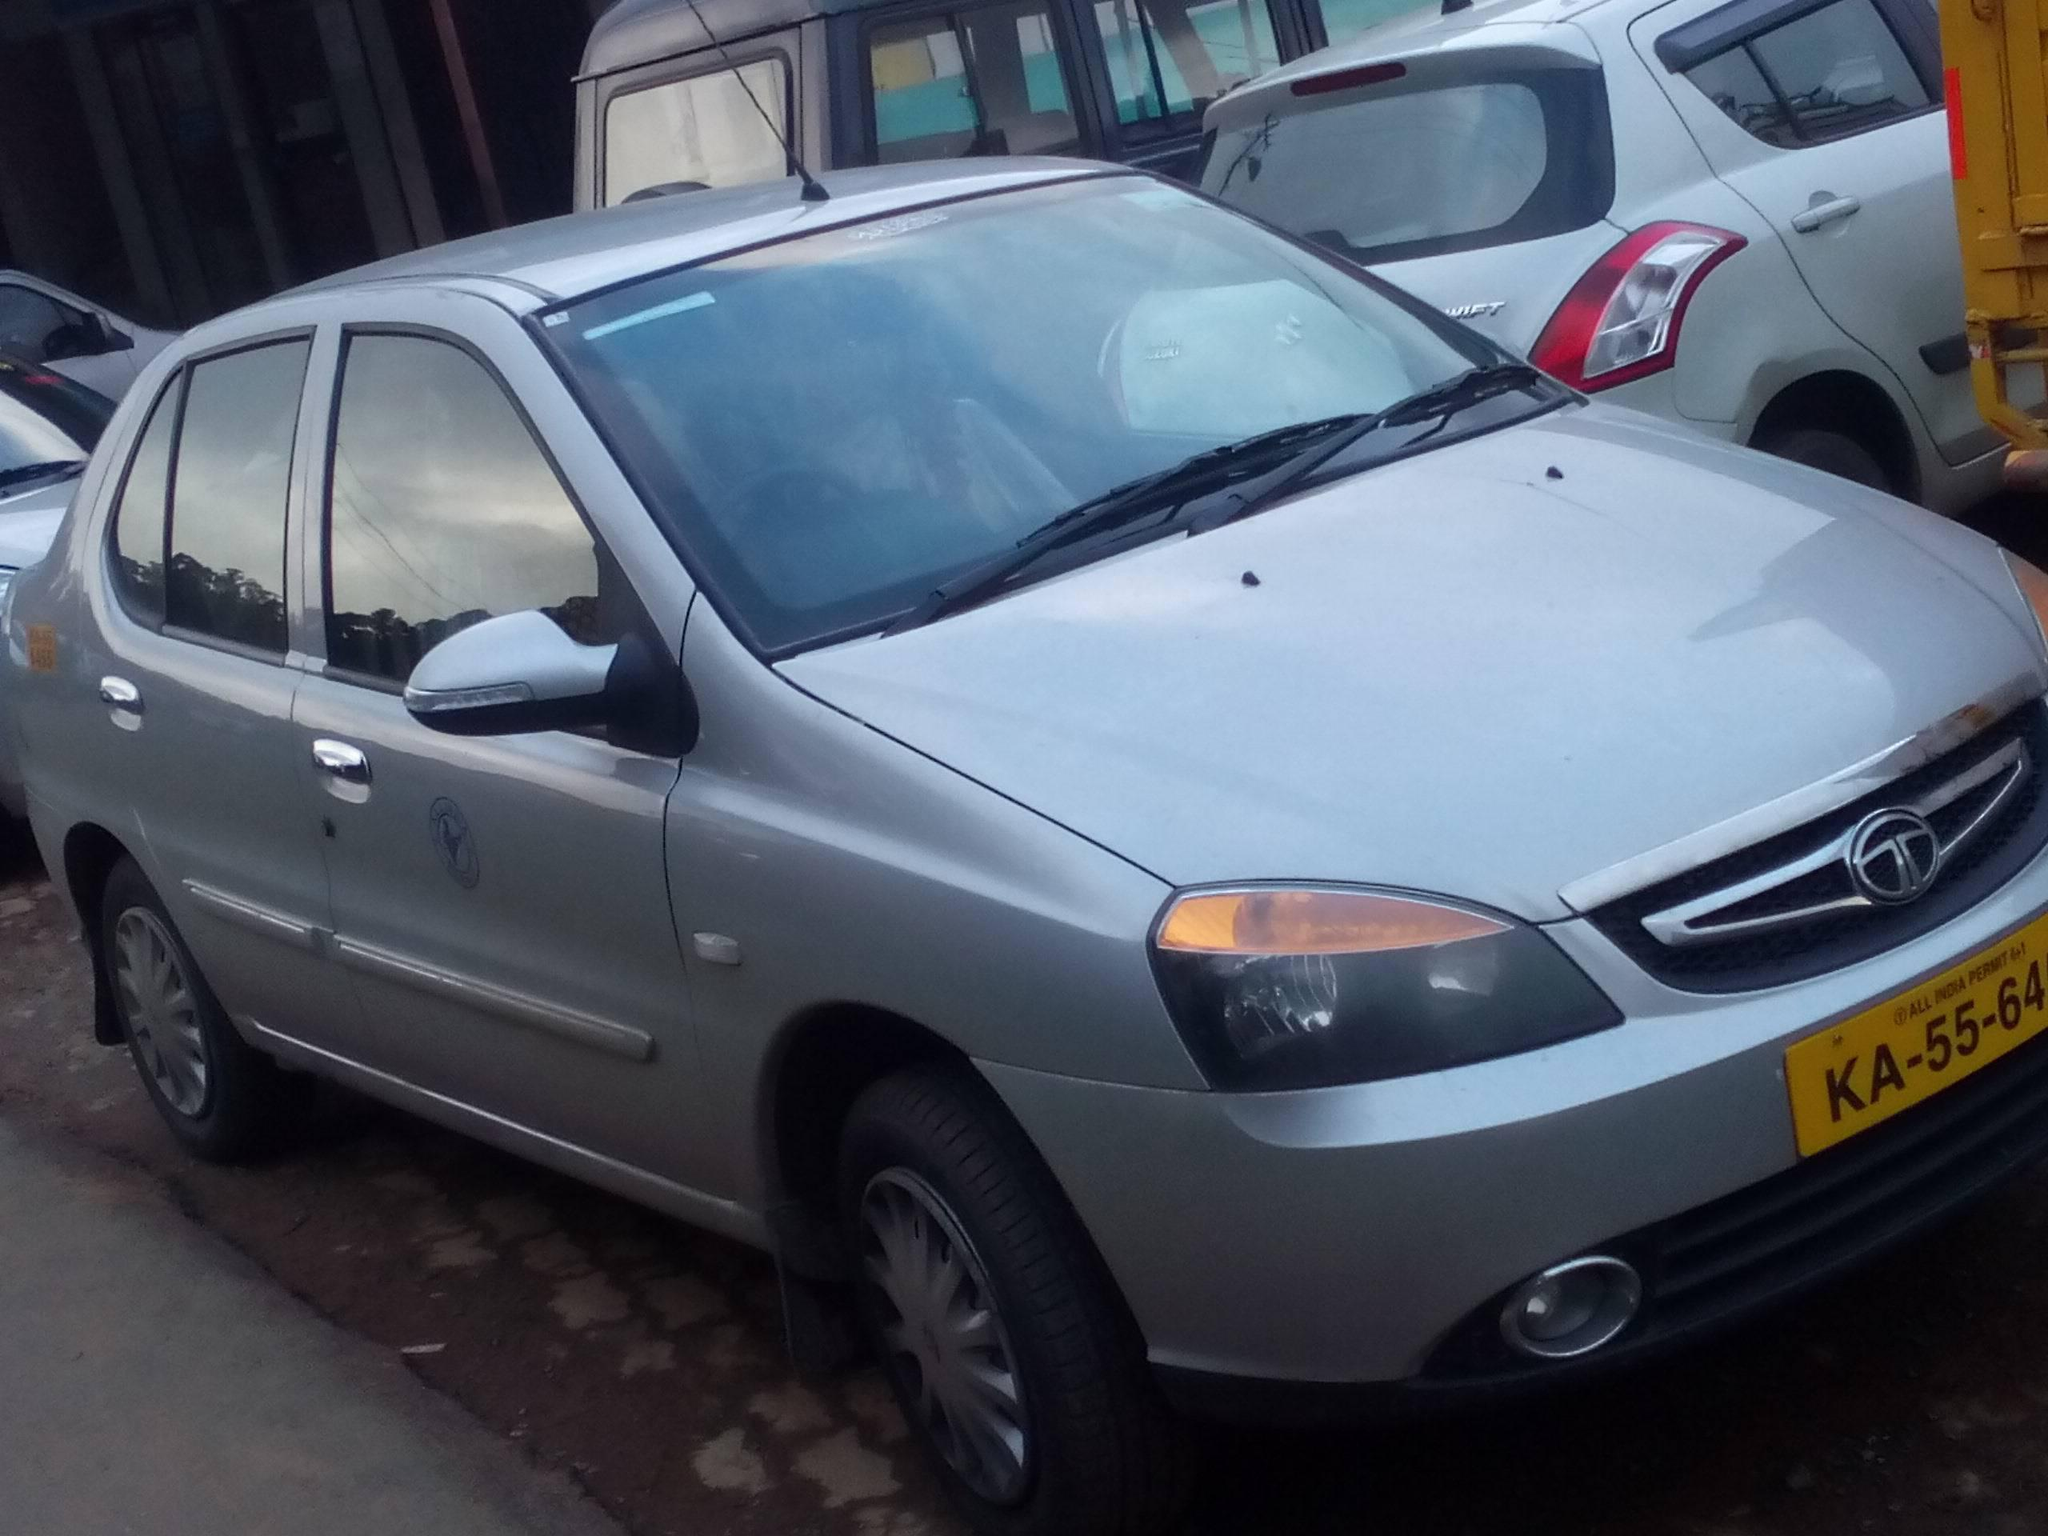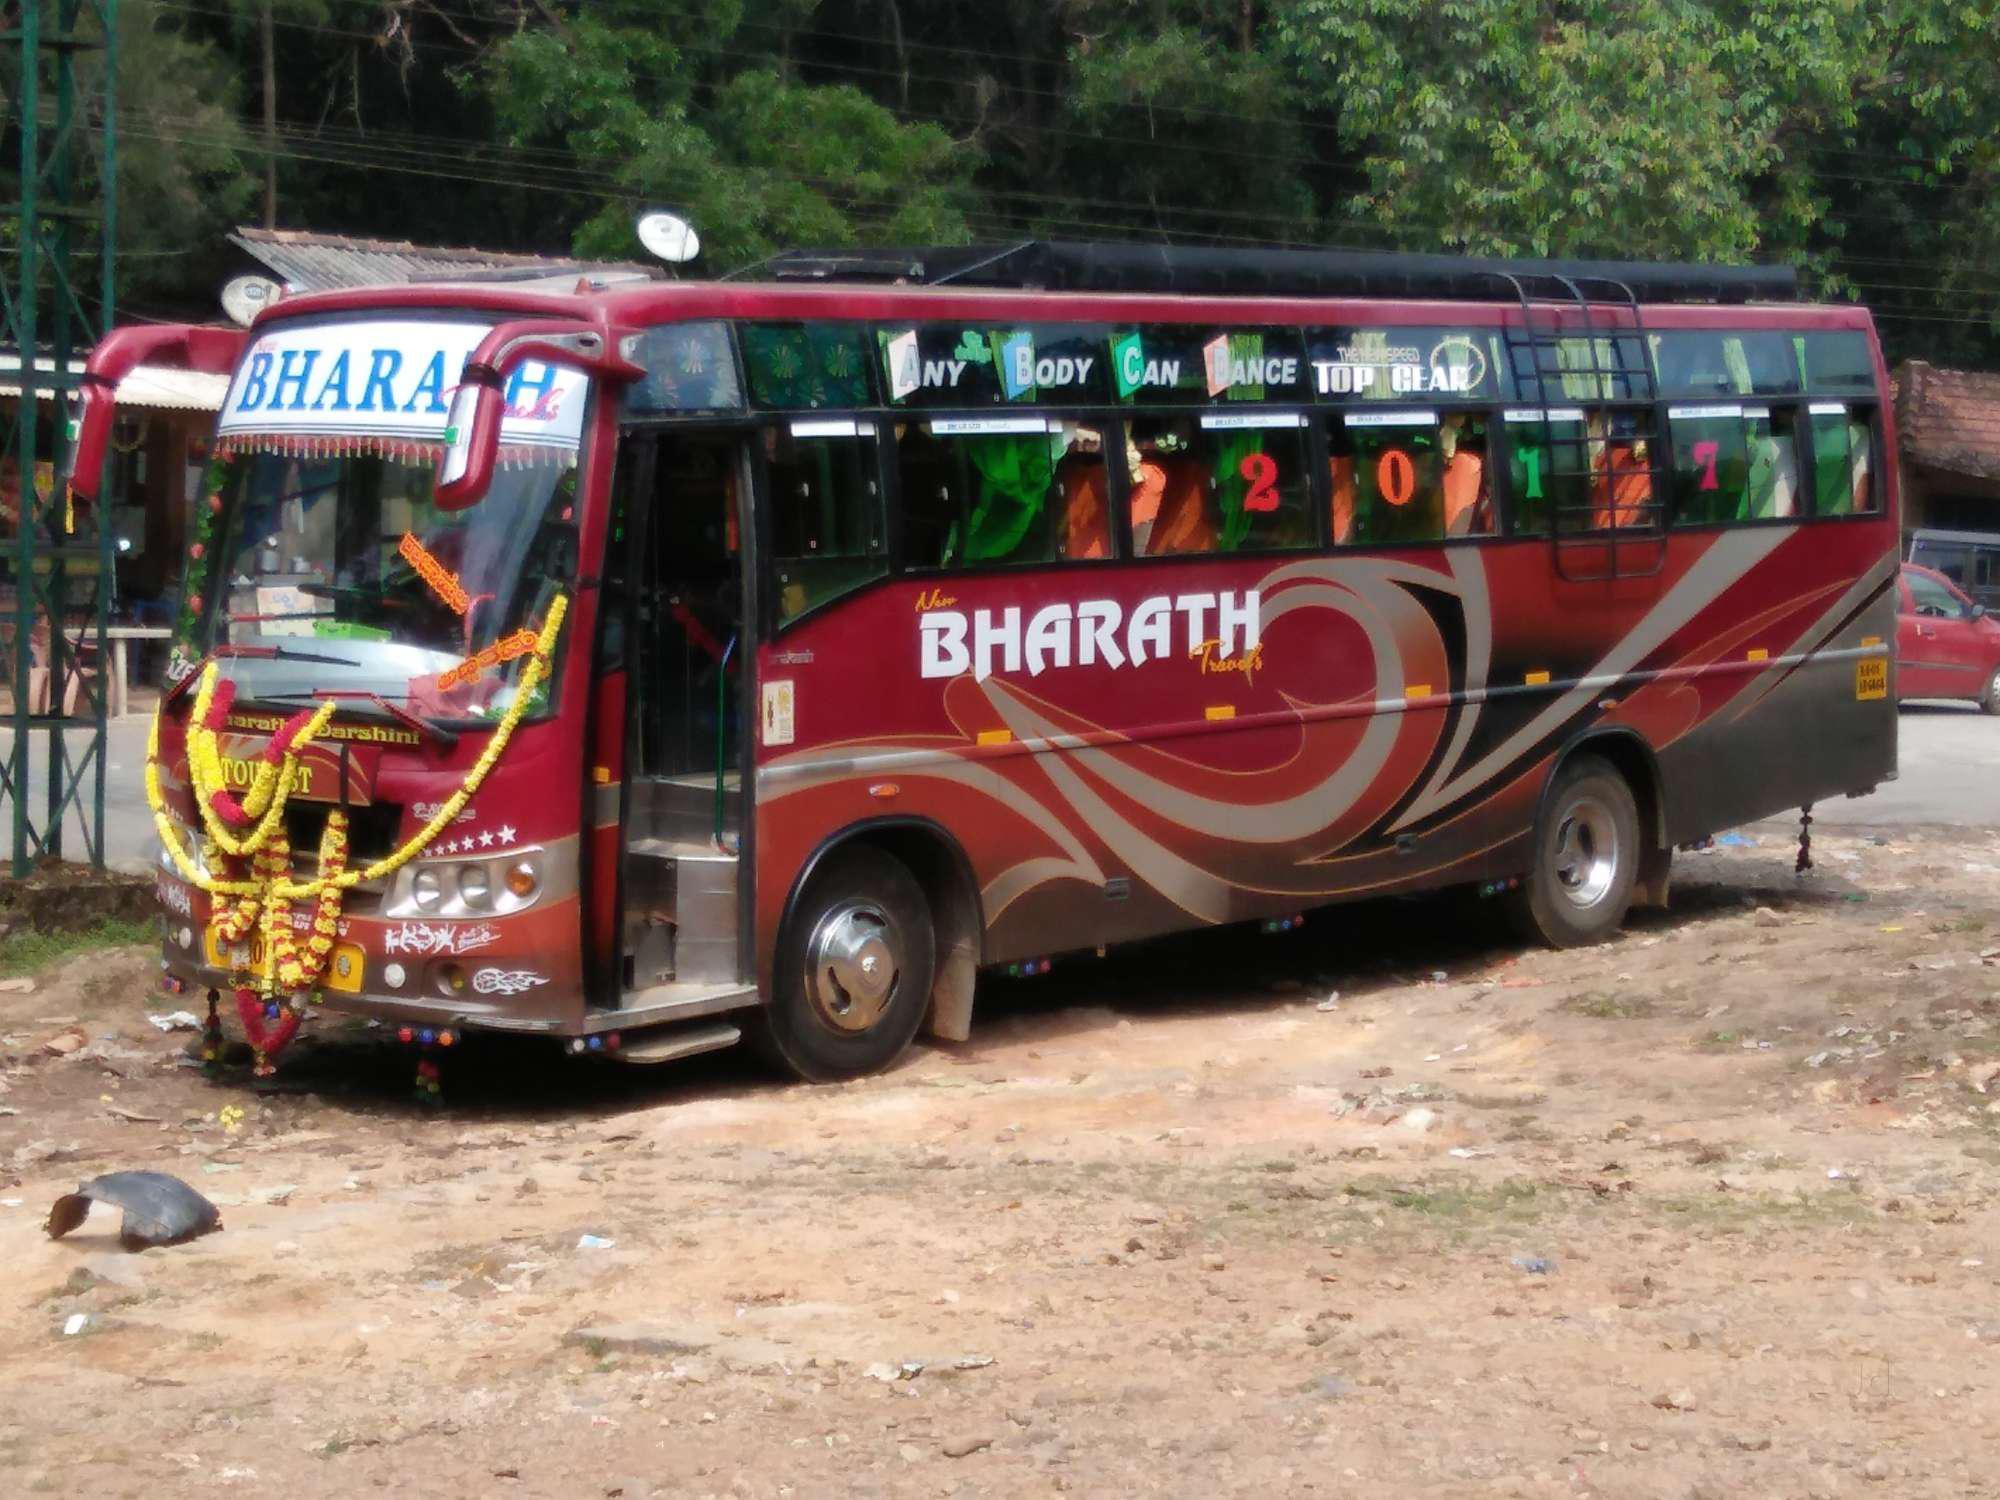The first image is the image on the left, the second image is the image on the right. Considering the images on both sides, is "The left image shows one primarily white bus with a flat, slightly sloped front displayed at an angle facing rightward." valid? Answer yes or no. No. The first image is the image on the left, the second image is the image on the right. For the images displayed, is the sentence "The left and right image contains the same number of travel buses." factually correct? Answer yes or no. No. 